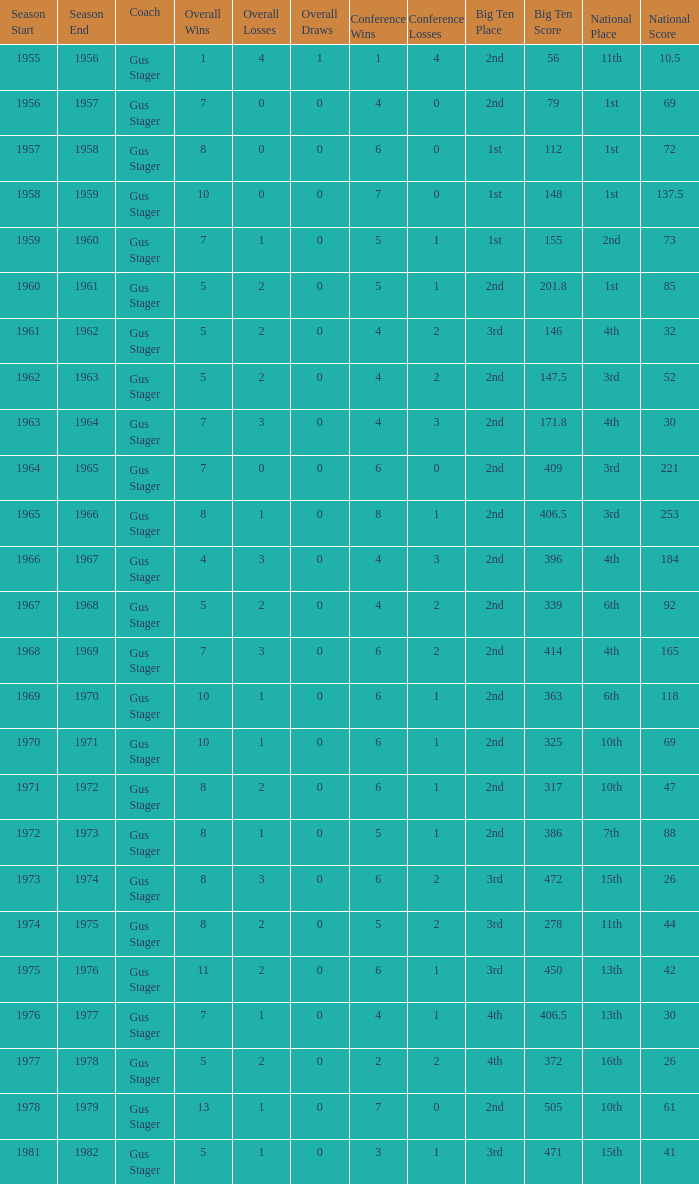What is the Coach with a Big Ten that is 1st (148)? Gus Stager. 